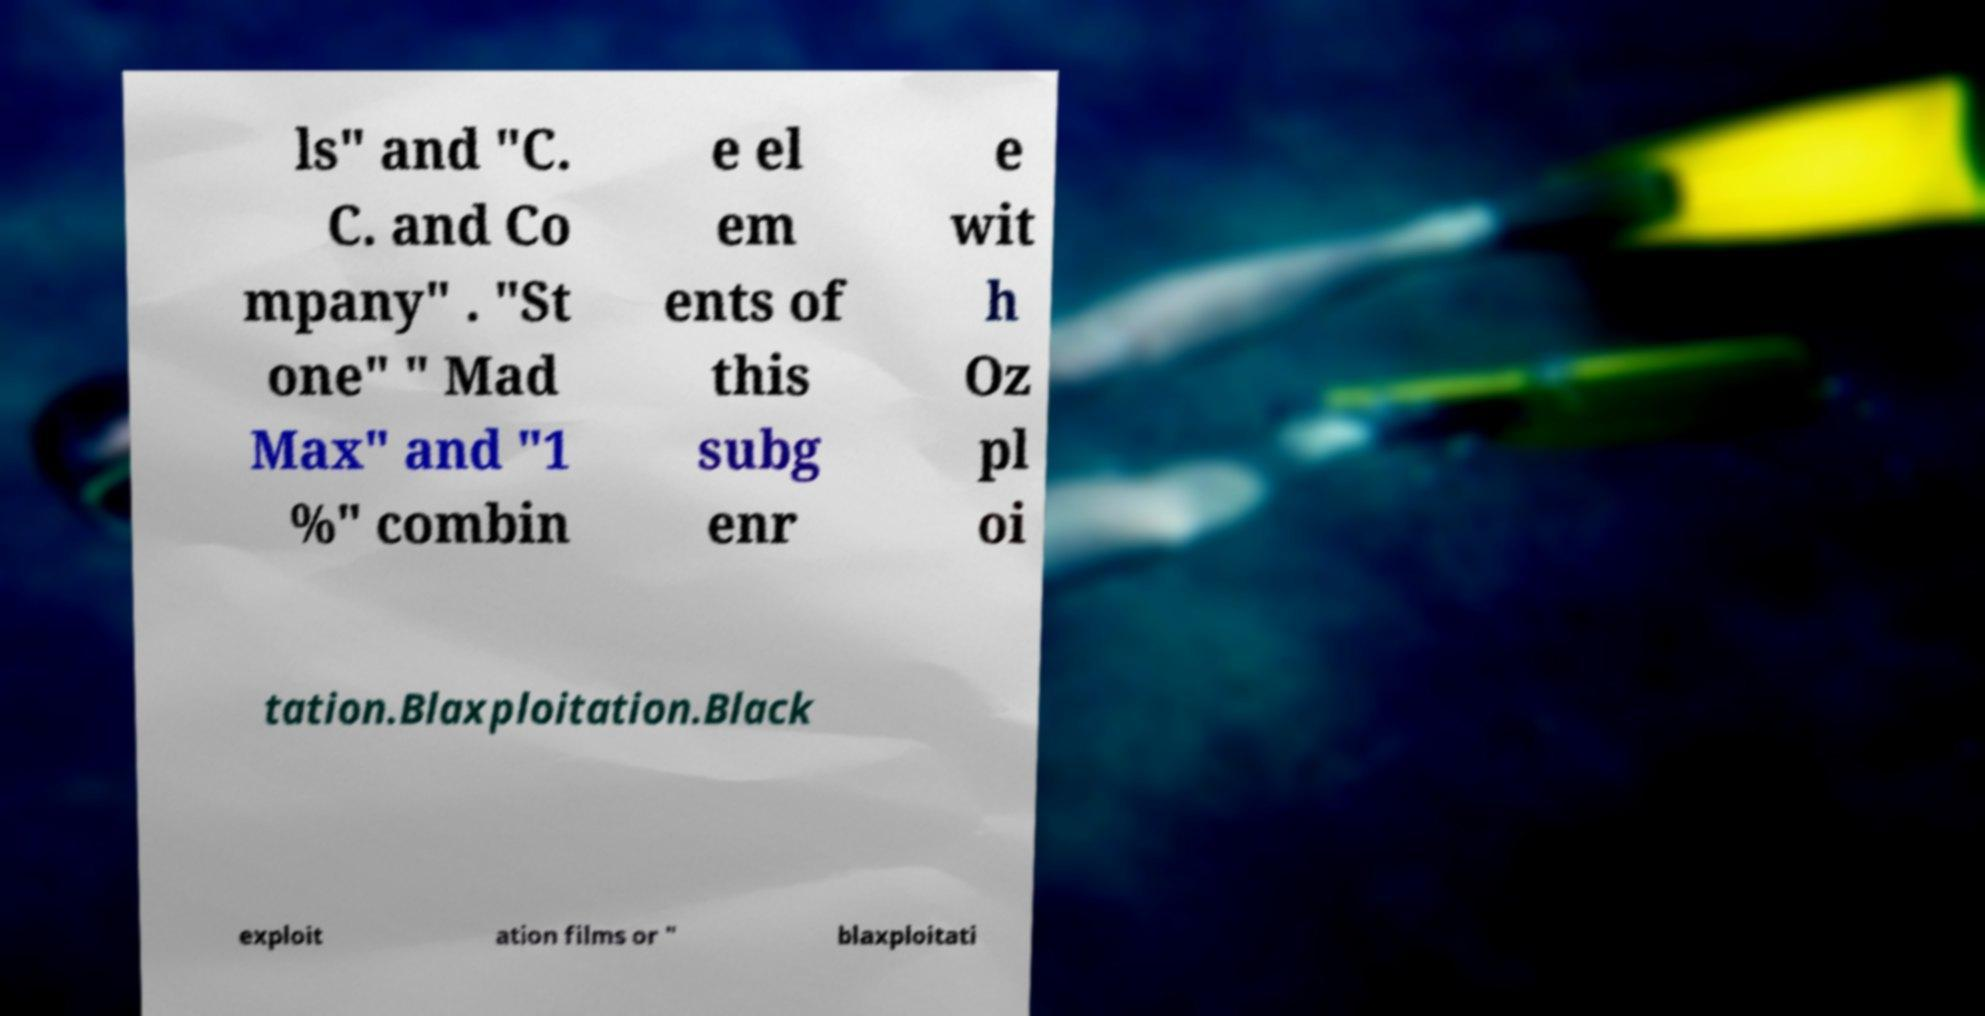Please read and relay the text visible in this image. What does it say? ls" and "C. C. and Co mpany" . "St one" " Mad Max" and "1 %" combin e el em ents of this subg enr e wit h Oz pl oi tation.Blaxploitation.Black exploit ation films or " blaxploitati 